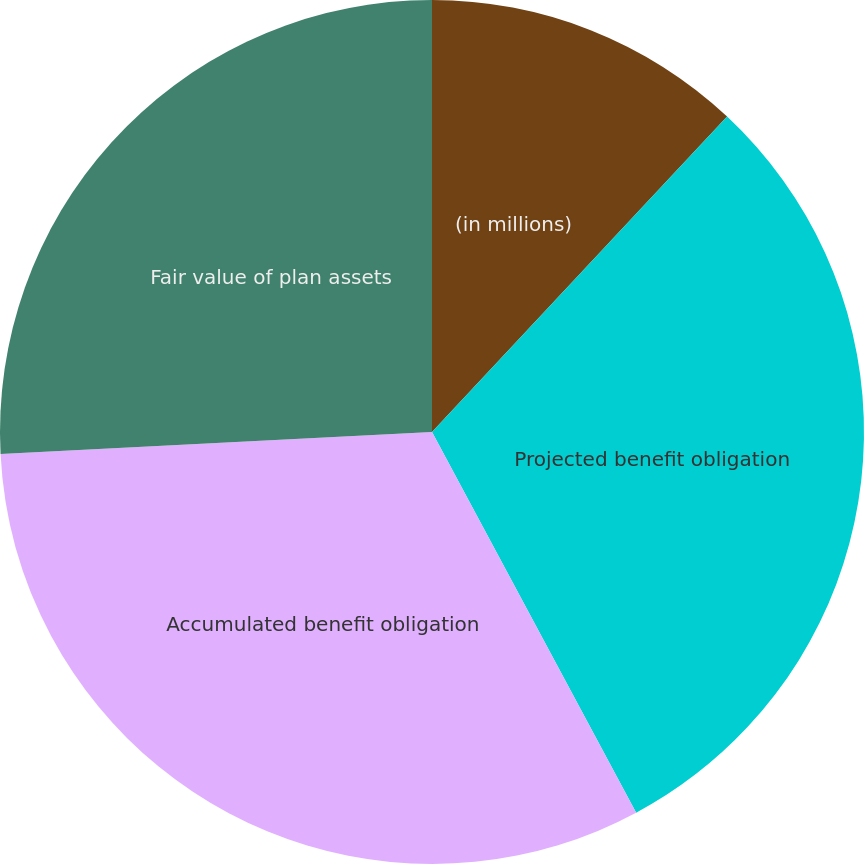Convert chart to OTSL. <chart><loc_0><loc_0><loc_500><loc_500><pie_chart><fcel>(in millions)<fcel>Projected benefit obligation<fcel>Accumulated benefit obligation<fcel>Fair value of plan assets<nl><fcel>11.97%<fcel>30.2%<fcel>32.03%<fcel>25.81%<nl></chart> 